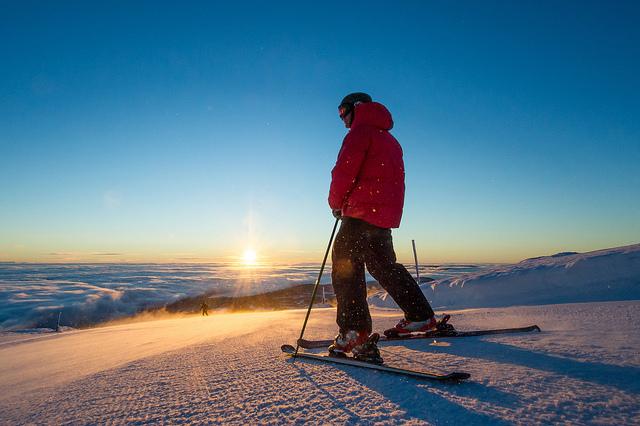What is under the man?
Concise answer only. Snow. What sport are they participating in?
Write a very short answer. Skiing. Is the sun going up or coming down?
Keep it brief. Down. How many people are watching him?
Be succinct. 0. Where is the man?
Concise answer only. Ski slope. How long has this snow been here?
Give a very brief answer. Months. How many skiers are on the slope?
Answer briefly. 1. What is the man doing?
Give a very brief answer. Skiing. What color jacket is she wearing?
Keep it brief. Red. What is the person doing?
Keep it brief. Skiing. What activity is this person partaking in?
Give a very brief answer. Skiing. What is the main color of this picture?
Be succinct. Blue. What is he holding in his hand?
Be succinct. Ski poles. How is the weather?
Short answer required. Cold. What is the young man doing?
Give a very brief answer. Skiing. What is the guy riding on?
Keep it brief. Skis. What color are the mans skis?
Answer briefly. Black. What is the composition of the ground?
Keep it brief. Snow. Have other people used this path?
Be succinct. Yes. Is the sky cloudy?
Quick response, please. No. What color is the person's jacket?
Quick response, please. Red. What is the kid riding on?
Keep it brief. Skis. What is the shadow?
Write a very short answer. Skier. What is in the picture?
Quick response, please. Skier. Is he standing on his feet?
Write a very short answer. Yes. What is this man doing?
Short answer required. Skiing. 